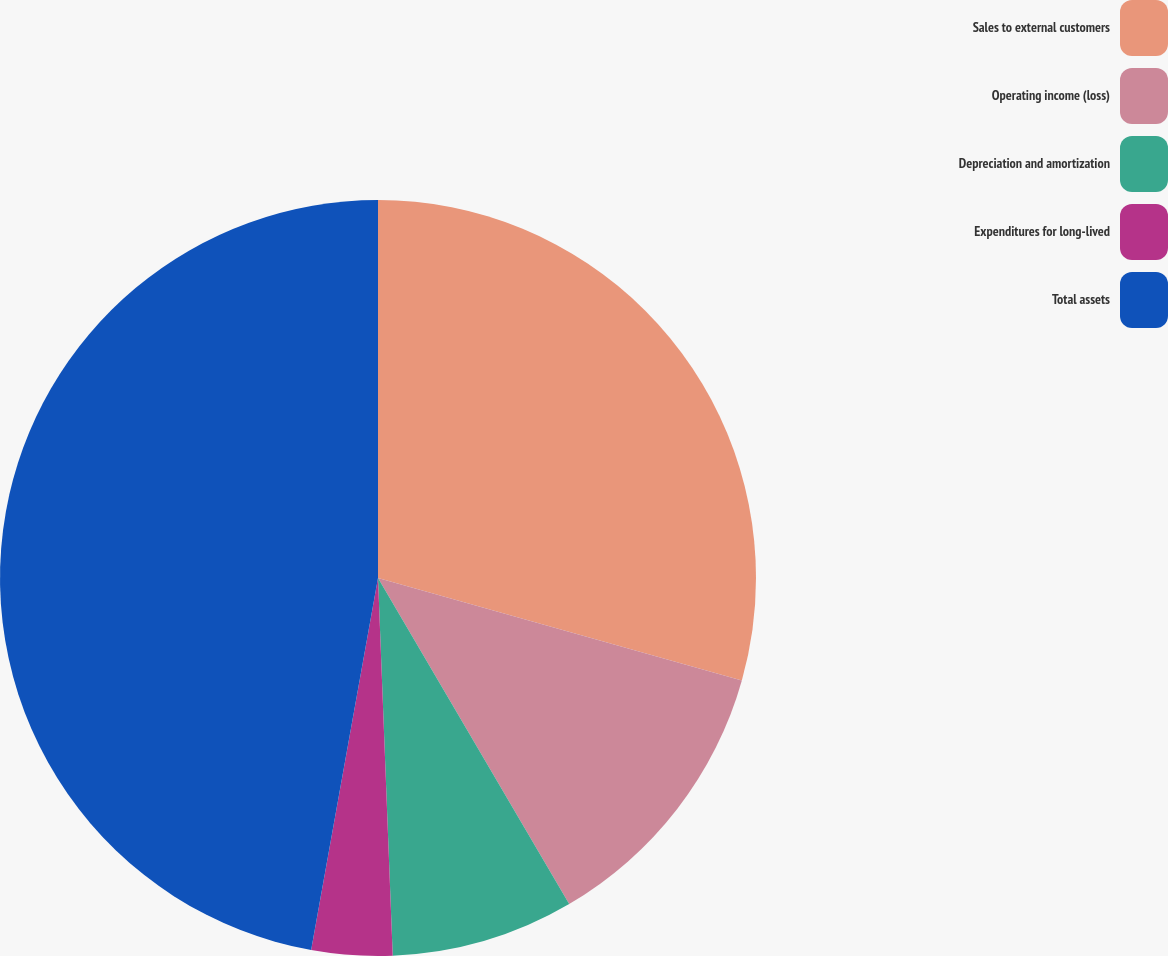<chart> <loc_0><loc_0><loc_500><loc_500><pie_chart><fcel>Sales to external customers<fcel>Operating income (loss)<fcel>Depreciation and amortization<fcel>Expenditures for long-lived<fcel>Total assets<nl><fcel>29.37%<fcel>12.19%<fcel>7.82%<fcel>3.45%<fcel>47.17%<nl></chart> 